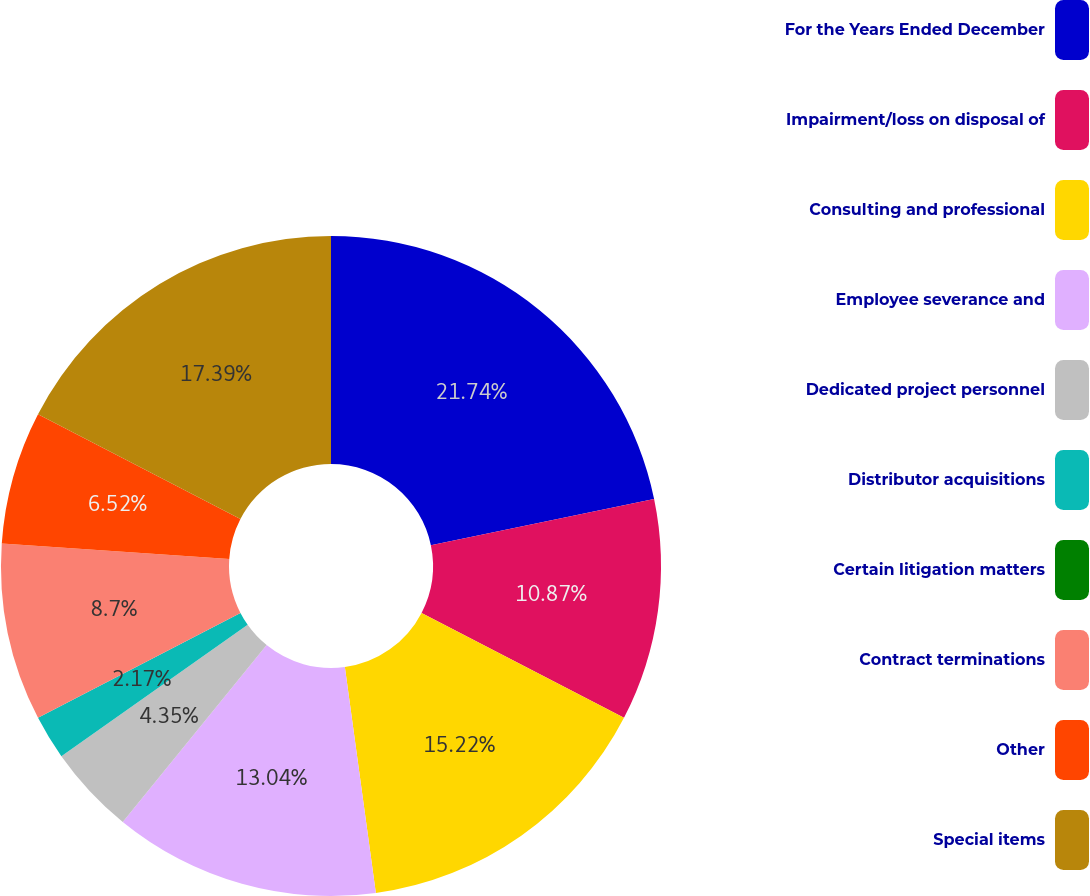Convert chart. <chart><loc_0><loc_0><loc_500><loc_500><pie_chart><fcel>For the Years Ended December<fcel>Impairment/loss on disposal of<fcel>Consulting and professional<fcel>Employee severance and<fcel>Dedicated project personnel<fcel>Distributor acquisitions<fcel>Certain litigation matters<fcel>Contract terminations<fcel>Other<fcel>Special items<nl><fcel>21.74%<fcel>10.87%<fcel>15.22%<fcel>13.04%<fcel>4.35%<fcel>2.17%<fcel>0.0%<fcel>8.7%<fcel>6.52%<fcel>17.39%<nl></chart> 